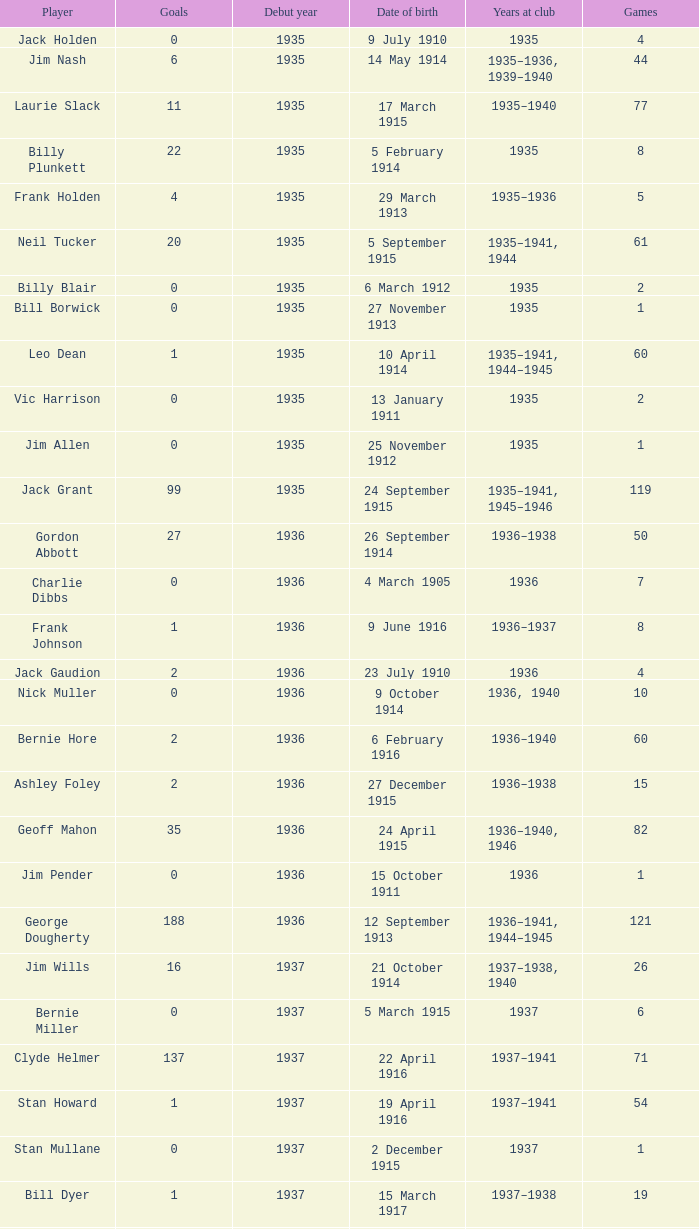How many games had 22 goals before 1935? None. 